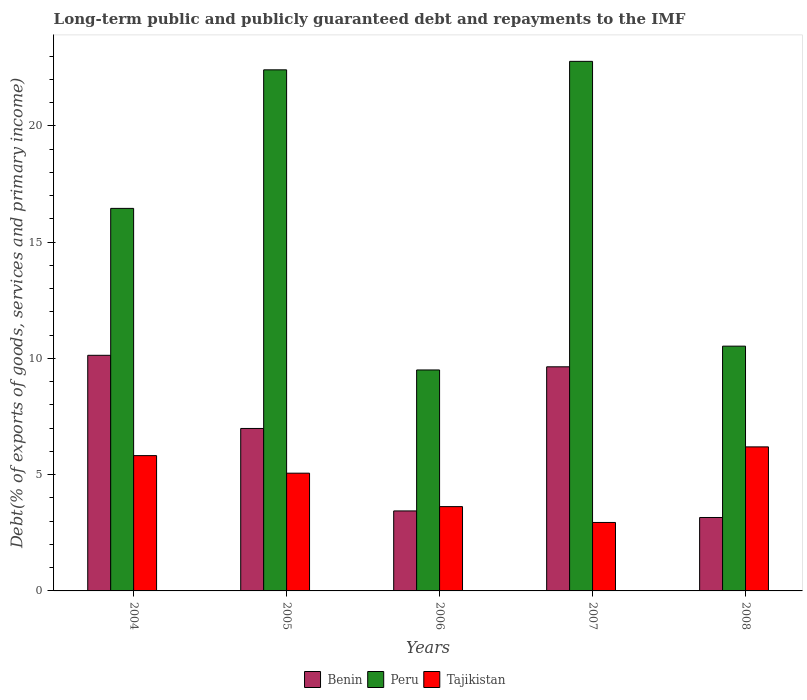How many different coloured bars are there?
Make the answer very short. 3. How many bars are there on the 3rd tick from the left?
Your answer should be compact. 3. What is the label of the 5th group of bars from the left?
Ensure brevity in your answer.  2008. In how many cases, is the number of bars for a given year not equal to the number of legend labels?
Provide a succinct answer. 0. What is the debt and repayments in Tajikistan in 2004?
Keep it short and to the point. 5.82. Across all years, what is the maximum debt and repayments in Tajikistan?
Your response must be concise. 6.19. Across all years, what is the minimum debt and repayments in Tajikistan?
Provide a short and direct response. 2.94. What is the total debt and repayments in Benin in the graph?
Provide a succinct answer. 33.35. What is the difference between the debt and repayments in Benin in 2004 and that in 2005?
Make the answer very short. 3.15. What is the difference between the debt and repayments in Benin in 2007 and the debt and repayments in Tajikistan in 2006?
Provide a succinct answer. 6.01. What is the average debt and repayments in Tajikistan per year?
Provide a succinct answer. 4.73. In the year 2007, what is the difference between the debt and repayments in Tajikistan and debt and repayments in Peru?
Your answer should be compact. -19.83. In how many years, is the debt and repayments in Tajikistan greater than 15 %?
Your response must be concise. 0. What is the ratio of the debt and repayments in Peru in 2006 to that in 2007?
Keep it short and to the point. 0.42. What is the difference between the highest and the second highest debt and repayments in Tajikistan?
Provide a succinct answer. 0.38. What is the difference between the highest and the lowest debt and repayments in Tajikistan?
Keep it short and to the point. 3.25. In how many years, is the debt and repayments in Benin greater than the average debt and repayments in Benin taken over all years?
Offer a very short reply. 3. Is the sum of the debt and repayments in Tajikistan in 2005 and 2007 greater than the maximum debt and repayments in Peru across all years?
Your answer should be very brief. No. What does the 1st bar from the right in 2005 represents?
Provide a short and direct response. Tajikistan. Is it the case that in every year, the sum of the debt and repayments in Peru and debt and repayments in Benin is greater than the debt and repayments in Tajikistan?
Give a very brief answer. Yes. How many years are there in the graph?
Provide a short and direct response. 5. Are the values on the major ticks of Y-axis written in scientific E-notation?
Your answer should be very brief. No. Does the graph contain grids?
Offer a terse response. No. How are the legend labels stacked?
Your answer should be very brief. Horizontal. What is the title of the graph?
Provide a succinct answer. Long-term public and publicly guaranteed debt and repayments to the IMF. Does "Slovenia" appear as one of the legend labels in the graph?
Offer a very short reply. No. What is the label or title of the X-axis?
Your answer should be compact. Years. What is the label or title of the Y-axis?
Provide a succinct answer. Debt(% of exports of goods, services and primary income). What is the Debt(% of exports of goods, services and primary income) of Benin in 2004?
Give a very brief answer. 10.13. What is the Debt(% of exports of goods, services and primary income) of Peru in 2004?
Your answer should be compact. 16.45. What is the Debt(% of exports of goods, services and primary income) of Tajikistan in 2004?
Provide a short and direct response. 5.82. What is the Debt(% of exports of goods, services and primary income) of Benin in 2005?
Offer a terse response. 6.99. What is the Debt(% of exports of goods, services and primary income) of Peru in 2005?
Your answer should be very brief. 22.41. What is the Debt(% of exports of goods, services and primary income) of Tajikistan in 2005?
Provide a short and direct response. 5.06. What is the Debt(% of exports of goods, services and primary income) in Benin in 2006?
Offer a terse response. 3.44. What is the Debt(% of exports of goods, services and primary income) in Peru in 2006?
Make the answer very short. 9.5. What is the Debt(% of exports of goods, services and primary income) in Tajikistan in 2006?
Make the answer very short. 3.63. What is the Debt(% of exports of goods, services and primary income) of Benin in 2007?
Make the answer very short. 9.64. What is the Debt(% of exports of goods, services and primary income) of Peru in 2007?
Keep it short and to the point. 22.77. What is the Debt(% of exports of goods, services and primary income) of Tajikistan in 2007?
Provide a short and direct response. 2.94. What is the Debt(% of exports of goods, services and primary income) of Benin in 2008?
Offer a terse response. 3.16. What is the Debt(% of exports of goods, services and primary income) in Peru in 2008?
Keep it short and to the point. 10.52. What is the Debt(% of exports of goods, services and primary income) in Tajikistan in 2008?
Provide a short and direct response. 6.19. Across all years, what is the maximum Debt(% of exports of goods, services and primary income) of Benin?
Offer a very short reply. 10.13. Across all years, what is the maximum Debt(% of exports of goods, services and primary income) in Peru?
Provide a succinct answer. 22.77. Across all years, what is the maximum Debt(% of exports of goods, services and primary income) in Tajikistan?
Keep it short and to the point. 6.19. Across all years, what is the minimum Debt(% of exports of goods, services and primary income) of Benin?
Your response must be concise. 3.16. Across all years, what is the minimum Debt(% of exports of goods, services and primary income) of Peru?
Ensure brevity in your answer.  9.5. Across all years, what is the minimum Debt(% of exports of goods, services and primary income) in Tajikistan?
Provide a short and direct response. 2.94. What is the total Debt(% of exports of goods, services and primary income) of Benin in the graph?
Keep it short and to the point. 33.35. What is the total Debt(% of exports of goods, services and primary income) in Peru in the graph?
Offer a terse response. 81.65. What is the total Debt(% of exports of goods, services and primary income) of Tajikistan in the graph?
Give a very brief answer. 23.64. What is the difference between the Debt(% of exports of goods, services and primary income) in Benin in 2004 and that in 2005?
Your answer should be very brief. 3.15. What is the difference between the Debt(% of exports of goods, services and primary income) in Peru in 2004 and that in 2005?
Your response must be concise. -5.96. What is the difference between the Debt(% of exports of goods, services and primary income) in Tajikistan in 2004 and that in 2005?
Ensure brevity in your answer.  0.76. What is the difference between the Debt(% of exports of goods, services and primary income) of Benin in 2004 and that in 2006?
Your response must be concise. 6.69. What is the difference between the Debt(% of exports of goods, services and primary income) of Peru in 2004 and that in 2006?
Your answer should be compact. 6.95. What is the difference between the Debt(% of exports of goods, services and primary income) in Tajikistan in 2004 and that in 2006?
Your response must be concise. 2.19. What is the difference between the Debt(% of exports of goods, services and primary income) in Benin in 2004 and that in 2007?
Offer a terse response. 0.49. What is the difference between the Debt(% of exports of goods, services and primary income) of Peru in 2004 and that in 2007?
Provide a succinct answer. -6.32. What is the difference between the Debt(% of exports of goods, services and primary income) in Tajikistan in 2004 and that in 2007?
Keep it short and to the point. 2.87. What is the difference between the Debt(% of exports of goods, services and primary income) in Benin in 2004 and that in 2008?
Make the answer very short. 6.97. What is the difference between the Debt(% of exports of goods, services and primary income) of Peru in 2004 and that in 2008?
Your answer should be very brief. 5.92. What is the difference between the Debt(% of exports of goods, services and primary income) in Tajikistan in 2004 and that in 2008?
Keep it short and to the point. -0.38. What is the difference between the Debt(% of exports of goods, services and primary income) of Benin in 2005 and that in 2006?
Your answer should be very brief. 3.55. What is the difference between the Debt(% of exports of goods, services and primary income) in Peru in 2005 and that in 2006?
Provide a short and direct response. 12.9. What is the difference between the Debt(% of exports of goods, services and primary income) of Tajikistan in 2005 and that in 2006?
Keep it short and to the point. 1.44. What is the difference between the Debt(% of exports of goods, services and primary income) in Benin in 2005 and that in 2007?
Offer a very short reply. -2.65. What is the difference between the Debt(% of exports of goods, services and primary income) in Peru in 2005 and that in 2007?
Offer a very short reply. -0.36. What is the difference between the Debt(% of exports of goods, services and primary income) in Tajikistan in 2005 and that in 2007?
Your answer should be very brief. 2.12. What is the difference between the Debt(% of exports of goods, services and primary income) in Benin in 2005 and that in 2008?
Keep it short and to the point. 3.83. What is the difference between the Debt(% of exports of goods, services and primary income) of Peru in 2005 and that in 2008?
Provide a short and direct response. 11.88. What is the difference between the Debt(% of exports of goods, services and primary income) of Tajikistan in 2005 and that in 2008?
Give a very brief answer. -1.13. What is the difference between the Debt(% of exports of goods, services and primary income) in Benin in 2006 and that in 2007?
Offer a very short reply. -6.2. What is the difference between the Debt(% of exports of goods, services and primary income) in Peru in 2006 and that in 2007?
Offer a very short reply. -13.27. What is the difference between the Debt(% of exports of goods, services and primary income) in Tajikistan in 2006 and that in 2007?
Provide a short and direct response. 0.68. What is the difference between the Debt(% of exports of goods, services and primary income) of Benin in 2006 and that in 2008?
Your answer should be compact. 0.28. What is the difference between the Debt(% of exports of goods, services and primary income) in Peru in 2006 and that in 2008?
Provide a succinct answer. -1.02. What is the difference between the Debt(% of exports of goods, services and primary income) of Tajikistan in 2006 and that in 2008?
Your answer should be compact. -2.57. What is the difference between the Debt(% of exports of goods, services and primary income) in Benin in 2007 and that in 2008?
Your answer should be compact. 6.48. What is the difference between the Debt(% of exports of goods, services and primary income) of Peru in 2007 and that in 2008?
Ensure brevity in your answer.  12.25. What is the difference between the Debt(% of exports of goods, services and primary income) in Tajikistan in 2007 and that in 2008?
Provide a succinct answer. -3.25. What is the difference between the Debt(% of exports of goods, services and primary income) of Benin in 2004 and the Debt(% of exports of goods, services and primary income) of Peru in 2005?
Give a very brief answer. -12.27. What is the difference between the Debt(% of exports of goods, services and primary income) of Benin in 2004 and the Debt(% of exports of goods, services and primary income) of Tajikistan in 2005?
Provide a short and direct response. 5.07. What is the difference between the Debt(% of exports of goods, services and primary income) of Peru in 2004 and the Debt(% of exports of goods, services and primary income) of Tajikistan in 2005?
Ensure brevity in your answer.  11.39. What is the difference between the Debt(% of exports of goods, services and primary income) in Benin in 2004 and the Debt(% of exports of goods, services and primary income) in Peru in 2006?
Your answer should be very brief. 0.63. What is the difference between the Debt(% of exports of goods, services and primary income) of Benin in 2004 and the Debt(% of exports of goods, services and primary income) of Tajikistan in 2006?
Your answer should be compact. 6.51. What is the difference between the Debt(% of exports of goods, services and primary income) of Peru in 2004 and the Debt(% of exports of goods, services and primary income) of Tajikistan in 2006?
Ensure brevity in your answer.  12.82. What is the difference between the Debt(% of exports of goods, services and primary income) of Benin in 2004 and the Debt(% of exports of goods, services and primary income) of Peru in 2007?
Give a very brief answer. -12.64. What is the difference between the Debt(% of exports of goods, services and primary income) in Benin in 2004 and the Debt(% of exports of goods, services and primary income) in Tajikistan in 2007?
Your response must be concise. 7.19. What is the difference between the Debt(% of exports of goods, services and primary income) of Peru in 2004 and the Debt(% of exports of goods, services and primary income) of Tajikistan in 2007?
Offer a very short reply. 13.5. What is the difference between the Debt(% of exports of goods, services and primary income) of Benin in 2004 and the Debt(% of exports of goods, services and primary income) of Peru in 2008?
Give a very brief answer. -0.39. What is the difference between the Debt(% of exports of goods, services and primary income) of Benin in 2004 and the Debt(% of exports of goods, services and primary income) of Tajikistan in 2008?
Provide a short and direct response. 3.94. What is the difference between the Debt(% of exports of goods, services and primary income) of Peru in 2004 and the Debt(% of exports of goods, services and primary income) of Tajikistan in 2008?
Offer a very short reply. 10.25. What is the difference between the Debt(% of exports of goods, services and primary income) in Benin in 2005 and the Debt(% of exports of goods, services and primary income) in Peru in 2006?
Your answer should be very brief. -2.52. What is the difference between the Debt(% of exports of goods, services and primary income) in Benin in 2005 and the Debt(% of exports of goods, services and primary income) in Tajikistan in 2006?
Ensure brevity in your answer.  3.36. What is the difference between the Debt(% of exports of goods, services and primary income) of Peru in 2005 and the Debt(% of exports of goods, services and primary income) of Tajikistan in 2006?
Ensure brevity in your answer.  18.78. What is the difference between the Debt(% of exports of goods, services and primary income) in Benin in 2005 and the Debt(% of exports of goods, services and primary income) in Peru in 2007?
Offer a very short reply. -15.78. What is the difference between the Debt(% of exports of goods, services and primary income) of Benin in 2005 and the Debt(% of exports of goods, services and primary income) of Tajikistan in 2007?
Ensure brevity in your answer.  4.04. What is the difference between the Debt(% of exports of goods, services and primary income) of Peru in 2005 and the Debt(% of exports of goods, services and primary income) of Tajikistan in 2007?
Offer a very short reply. 19.46. What is the difference between the Debt(% of exports of goods, services and primary income) of Benin in 2005 and the Debt(% of exports of goods, services and primary income) of Peru in 2008?
Provide a succinct answer. -3.54. What is the difference between the Debt(% of exports of goods, services and primary income) of Benin in 2005 and the Debt(% of exports of goods, services and primary income) of Tajikistan in 2008?
Give a very brief answer. 0.79. What is the difference between the Debt(% of exports of goods, services and primary income) in Peru in 2005 and the Debt(% of exports of goods, services and primary income) in Tajikistan in 2008?
Your answer should be compact. 16.21. What is the difference between the Debt(% of exports of goods, services and primary income) of Benin in 2006 and the Debt(% of exports of goods, services and primary income) of Peru in 2007?
Your answer should be very brief. -19.33. What is the difference between the Debt(% of exports of goods, services and primary income) in Benin in 2006 and the Debt(% of exports of goods, services and primary income) in Tajikistan in 2007?
Offer a terse response. 0.5. What is the difference between the Debt(% of exports of goods, services and primary income) of Peru in 2006 and the Debt(% of exports of goods, services and primary income) of Tajikistan in 2007?
Your answer should be compact. 6.56. What is the difference between the Debt(% of exports of goods, services and primary income) in Benin in 2006 and the Debt(% of exports of goods, services and primary income) in Peru in 2008?
Your answer should be compact. -7.08. What is the difference between the Debt(% of exports of goods, services and primary income) in Benin in 2006 and the Debt(% of exports of goods, services and primary income) in Tajikistan in 2008?
Make the answer very short. -2.75. What is the difference between the Debt(% of exports of goods, services and primary income) of Peru in 2006 and the Debt(% of exports of goods, services and primary income) of Tajikistan in 2008?
Your answer should be compact. 3.31. What is the difference between the Debt(% of exports of goods, services and primary income) of Benin in 2007 and the Debt(% of exports of goods, services and primary income) of Peru in 2008?
Provide a succinct answer. -0.89. What is the difference between the Debt(% of exports of goods, services and primary income) of Benin in 2007 and the Debt(% of exports of goods, services and primary income) of Tajikistan in 2008?
Your answer should be very brief. 3.44. What is the difference between the Debt(% of exports of goods, services and primary income) of Peru in 2007 and the Debt(% of exports of goods, services and primary income) of Tajikistan in 2008?
Keep it short and to the point. 16.58. What is the average Debt(% of exports of goods, services and primary income) of Benin per year?
Ensure brevity in your answer.  6.67. What is the average Debt(% of exports of goods, services and primary income) in Peru per year?
Your answer should be compact. 16.33. What is the average Debt(% of exports of goods, services and primary income) in Tajikistan per year?
Offer a terse response. 4.73. In the year 2004, what is the difference between the Debt(% of exports of goods, services and primary income) of Benin and Debt(% of exports of goods, services and primary income) of Peru?
Your answer should be compact. -6.32. In the year 2004, what is the difference between the Debt(% of exports of goods, services and primary income) in Benin and Debt(% of exports of goods, services and primary income) in Tajikistan?
Your response must be concise. 4.31. In the year 2004, what is the difference between the Debt(% of exports of goods, services and primary income) in Peru and Debt(% of exports of goods, services and primary income) in Tajikistan?
Your response must be concise. 10.63. In the year 2005, what is the difference between the Debt(% of exports of goods, services and primary income) of Benin and Debt(% of exports of goods, services and primary income) of Peru?
Offer a terse response. -15.42. In the year 2005, what is the difference between the Debt(% of exports of goods, services and primary income) of Benin and Debt(% of exports of goods, services and primary income) of Tajikistan?
Offer a terse response. 1.92. In the year 2005, what is the difference between the Debt(% of exports of goods, services and primary income) of Peru and Debt(% of exports of goods, services and primary income) of Tajikistan?
Your response must be concise. 17.34. In the year 2006, what is the difference between the Debt(% of exports of goods, services and primary income) of Benin and Debt(% of exports of goods, services and primary income) of Peru?
Your answer should be compact. -6.06. In the year 2006, what is the difference between the Debt(% of exports of goods, services and primary income) of Benin and Debt(% of exports of goods, services and primary income) of Tajikistan?
Give a very brief answer. -0.19. In the year 2006, what is the difference between the Debt(% of exports of goods, services and primary income) in Peru and Debt(% of exports of goods, services and primary income) in Tajikistan?
Ensure brevity in your answer.  5.88. In the year 2007, what is the difference between the Debt(% of exports of goods, services and primary income) in Benin and Debt(% of exports of goods, services and primary income) in Peru?
Ensure brevity in your answer.  -13.13. In the year 2007, what is the difference between the Debt(% of exports of goods, services and primary income) in Benin and Debt(% of exports of goods, services and primary income) in Tajikistan?
Your answer should be compact. 6.69. In the year 2007, what is the difference between the Debt(% of exports of goods, services and primary income) in Peru and Debt(% of exports of goods, services and primary income) in Tajikistan?
Your answer should be compact. 19.83. In the year 2008, what is the difference between the Debt(% of exports of goods, services and primary income) of Benin and Debt(% of exports of goods, services and primary income) of Peru?
Offer a very short reply. -7.37. In the year 2008, what is the difference between the Debt(% of exports of goods, services and primary income) of Benin and Debt(% of exports of goods, services and primary income) of Tajikistan?
Provide a succinct answer. -3.04. In the year 2008, what is the difference between the Debt(% of exports of goods, services and primary income) of Peru and Debt(% of exports of goods, services and primary income) of Tajikistan?
Provide a short and direct response. 4.33. What is the ratio of the Debt(% of exports of goods, services and primary income) in Benin in 2004 to that in 2005?
Provide a short and direct response. 1.45. What is the ratio of the Debt(% of exports of goods, services and primary income) in Peru in 2004 to that in 2005?
Keep it short and to the point. 0.73. What is the ratio of the Debt(% of exports of goods, services and primary income) of Tajikistan in 2004 to that in 2005?
Provide a succinct answer. 1.15. What is the ratio of the Debt(% of exports of goods, services and primary income) of Benin in 2004 to that in 2006?
Give a very brief answer. 2.95. What is the ratio of the Debt(% of exports of goods, services and primary income) of Peru in 2004 to that in 2006?
Give a very brief answer. 1.73. What is the ratio of the Debt(% of exports of goods, services and primary income) of Tajikistan in 2004 to that in 2006?
Provide a short and direct response. 1.6. What is the ratio of the Debt(% of exports of goods, services and primary income) of Benin in 2004 to that in 2007?
Your response must be concise. 1.05. What is the ratio of the Debt(% of exports of goods, services and primary income) in Peru in 2004 to that in 2007?
Provide a short and direct response. 0.72. What is the ratio of the Debt(% of exports of goods, services and primary income) in Tajikistan in 2004 to that in 2007?
Your answer should be compact. 1.98. What is the ratio of the Debt(% of exports of goods, services and primary income) of Benin in 2004 to that in 2008?
Your answer should be compact. 3.21. What is the ratio of the Debt(% of exports of goods, services and primary income) of Peru in 2004 to that in 2008?
Give a very brief answer. 1.56. What is the ratio of the Debt(% of exports of goods, services and primary income) in Tajikistan in 2004 to that in 2008?
Keep it short and to the point. 0.94. What is the ratio of the Debt(% of exports of goods, services and primary income) of Benin in 2005 to that in 2006?
Offer a terse response. 2.03. What is the ratio of the Debt(% of exports of goods, services and primary income) in Peru in 2005 to that in 2006?
Your response must be concise. 2.36. What is the ratio of the Debt(% of exports of goods, services and primary income) of Tajikistan in 2005 to that in 2006?
Your answer should be very brief. 1.4. What is the ratio of the Debt(% of exports of goods, services and primary income) of Benin in 2005 to that in 2007?
Your response must be concise. 0.72. What is the ratio of the Debt(% of exports of goods, services and primary income) of Peru in 2005 to that in 2007?
Offer a very short reply. 0.98. What is the ratio of the Debt(% of exports of goods, services and primary income) in Tajikistan in 2005 to that in 2007?
Your answer should be compact. 1.72. What is the ratio of the Debt(% of exports of goods, services and primary income) in Benin in 2005 to that in 2008?
Offer a terse response. 2.21. What is the ratio of the Debt(% of exports of goods, services and primary income) of Peru in 2005 to that in 2008?
Your response must be concise. 2.13. What is the ratio of the Debt(% of exports of goods, services and primary income) of Tajikistan in 2005 to that in 2008?
Keep it short and to the point. 0.82. What is the ratio of the Debt(% of exports of goods, services and primary income) of Benin in 2006 to that in 2007?
Ensure brevity in your answer.  0.36. What is the ratio of the Debt(% of exports of goods, services and primary income) in Peru in 2006 to that in 2007?
Ensure brevity in your answer.  0.42. What is the ratio of the Debt(% of exports of goods, services and primary income) of Tajikistan in 2006 to that in 2007?
Your response must be concise. 1.23. What is the ratio of the Debt(% of exports of goods, services and primary income) of Benin in 2006 to that in 2008?
Offer a very short reply. 1.09. What is the ratio of the Debt(% of exports of goods, services and primary income) in Peru in 2006 to that in 2008?
Make the answer very short. 0.9. What is the ratio of the Debt(% of exports of goods, services and primary income) of Tajikistan in 2006 to that in 2008?
Offer a terse response. 0.59. What is the ratio of the Debt(% of exports of goods, services and primary income) of Benin in 2007 to that in 2008?
Give a very brief answer. 3.05. What is the ratio of the Debt(% of exports of goods, services and primary income) of Peru in 2007 to that in 2008?
Provide a short and direct response. 2.16. What is the ratio of the Debt(% of exports of goods, services and primary income) of Tajikistan in 2007 to that in 2008?
Give a very brief answer. 0.48. What is the difference between the highest and the second highest Debt(% of exports of goods, services and primary income) in Benin?
Provide a succinct answer. 0.49. What is the difference between the highest and the second highest Debt(% of exports of goods, services and primary income) of Peru?
Offer a very short reply. 0.36. What is the difference between the highest and the second highest Debt(% of exports of goods, services and primary income) of Tajikistan?
Offer a terse response. 0.38. What is the difference between the highest and the lowest Debt(% of exports of goods, services and primary income) in Benin?
Provide a succinct answer. 6.97. What is the difference between the highest and the lowest Debt(% of exports of goods, services and primary income) of Peru?
Your answer should be very brief. 13.27. What is the difference between the highest and the lowest Debt(% of exports of goods, services and primary income) in Tajikistan?
Your answer should be compact. 3.25. 